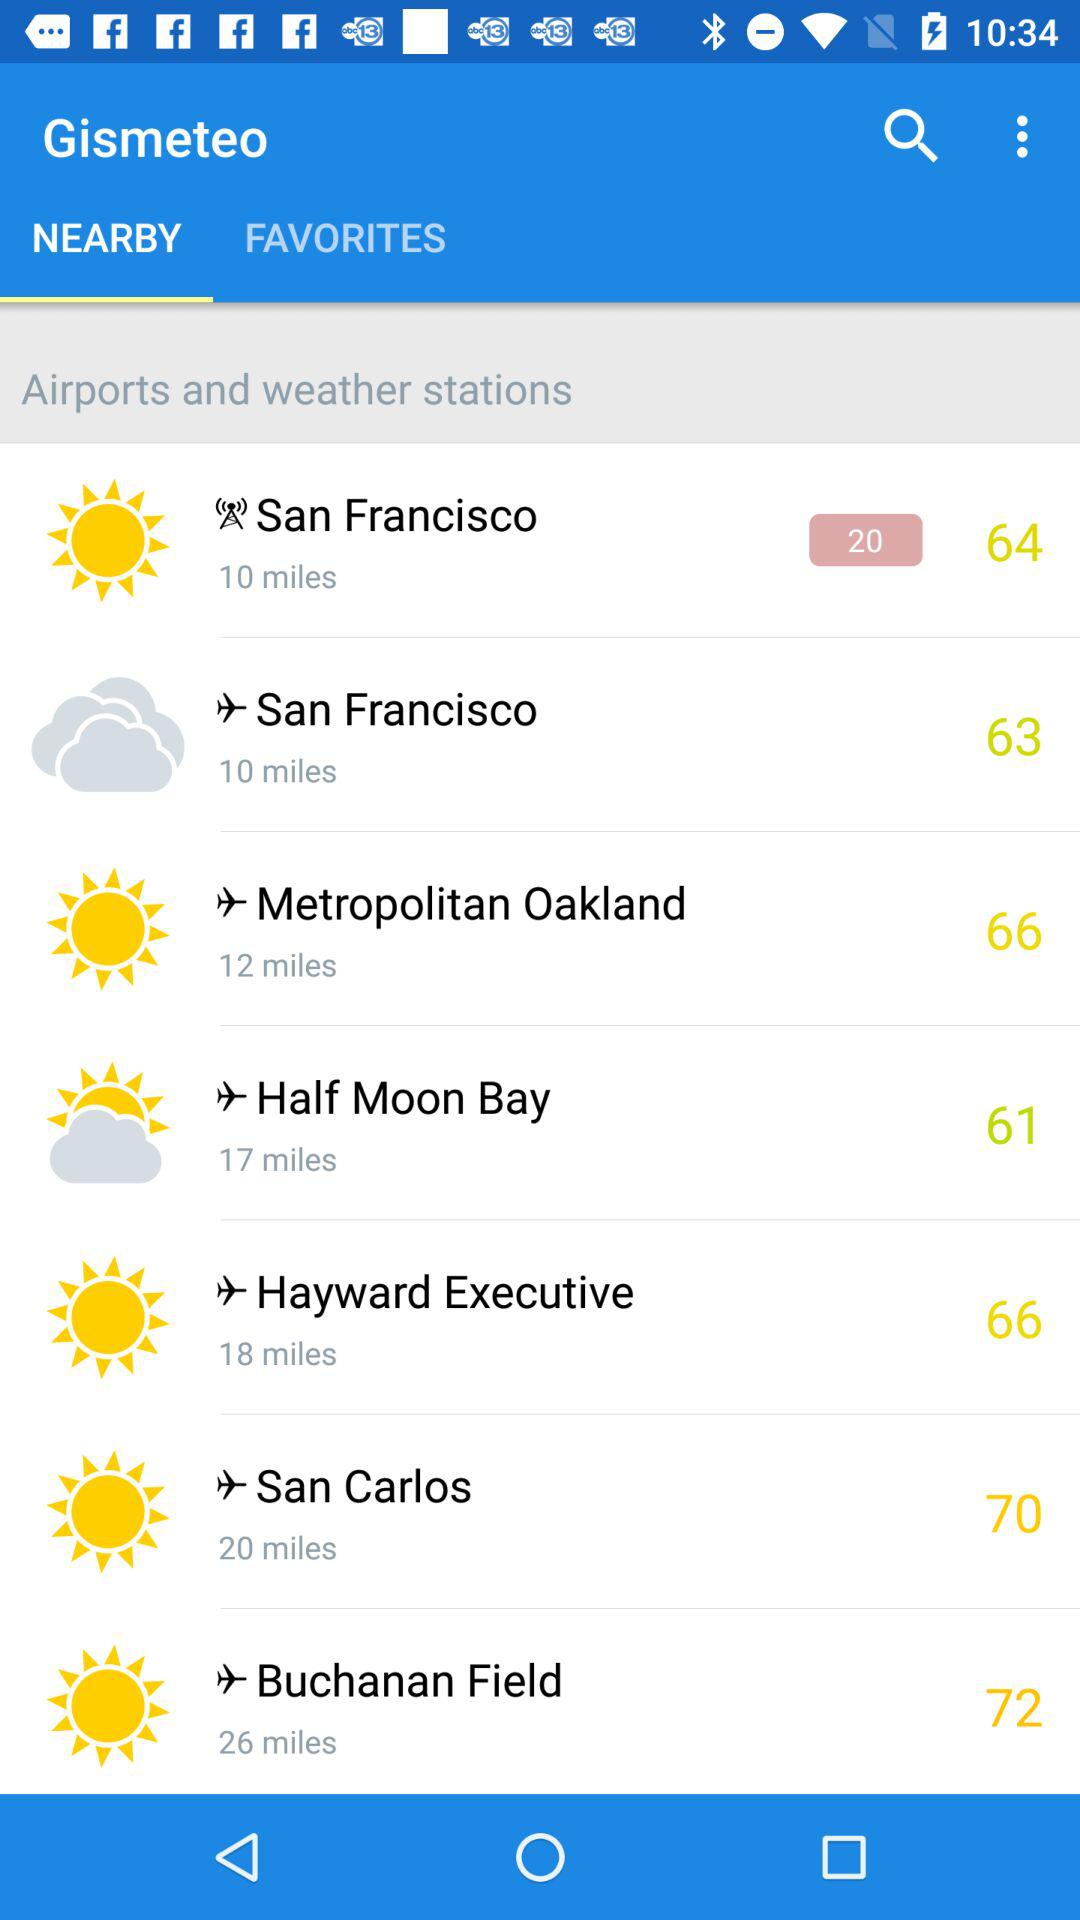How far is San Francisco? San Francisco is 10 miles away. 